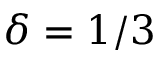Convert formula to latex. <formula><loc_0><loc_0><loc_500><loc_500>\delta = 1 / 3</formula> 